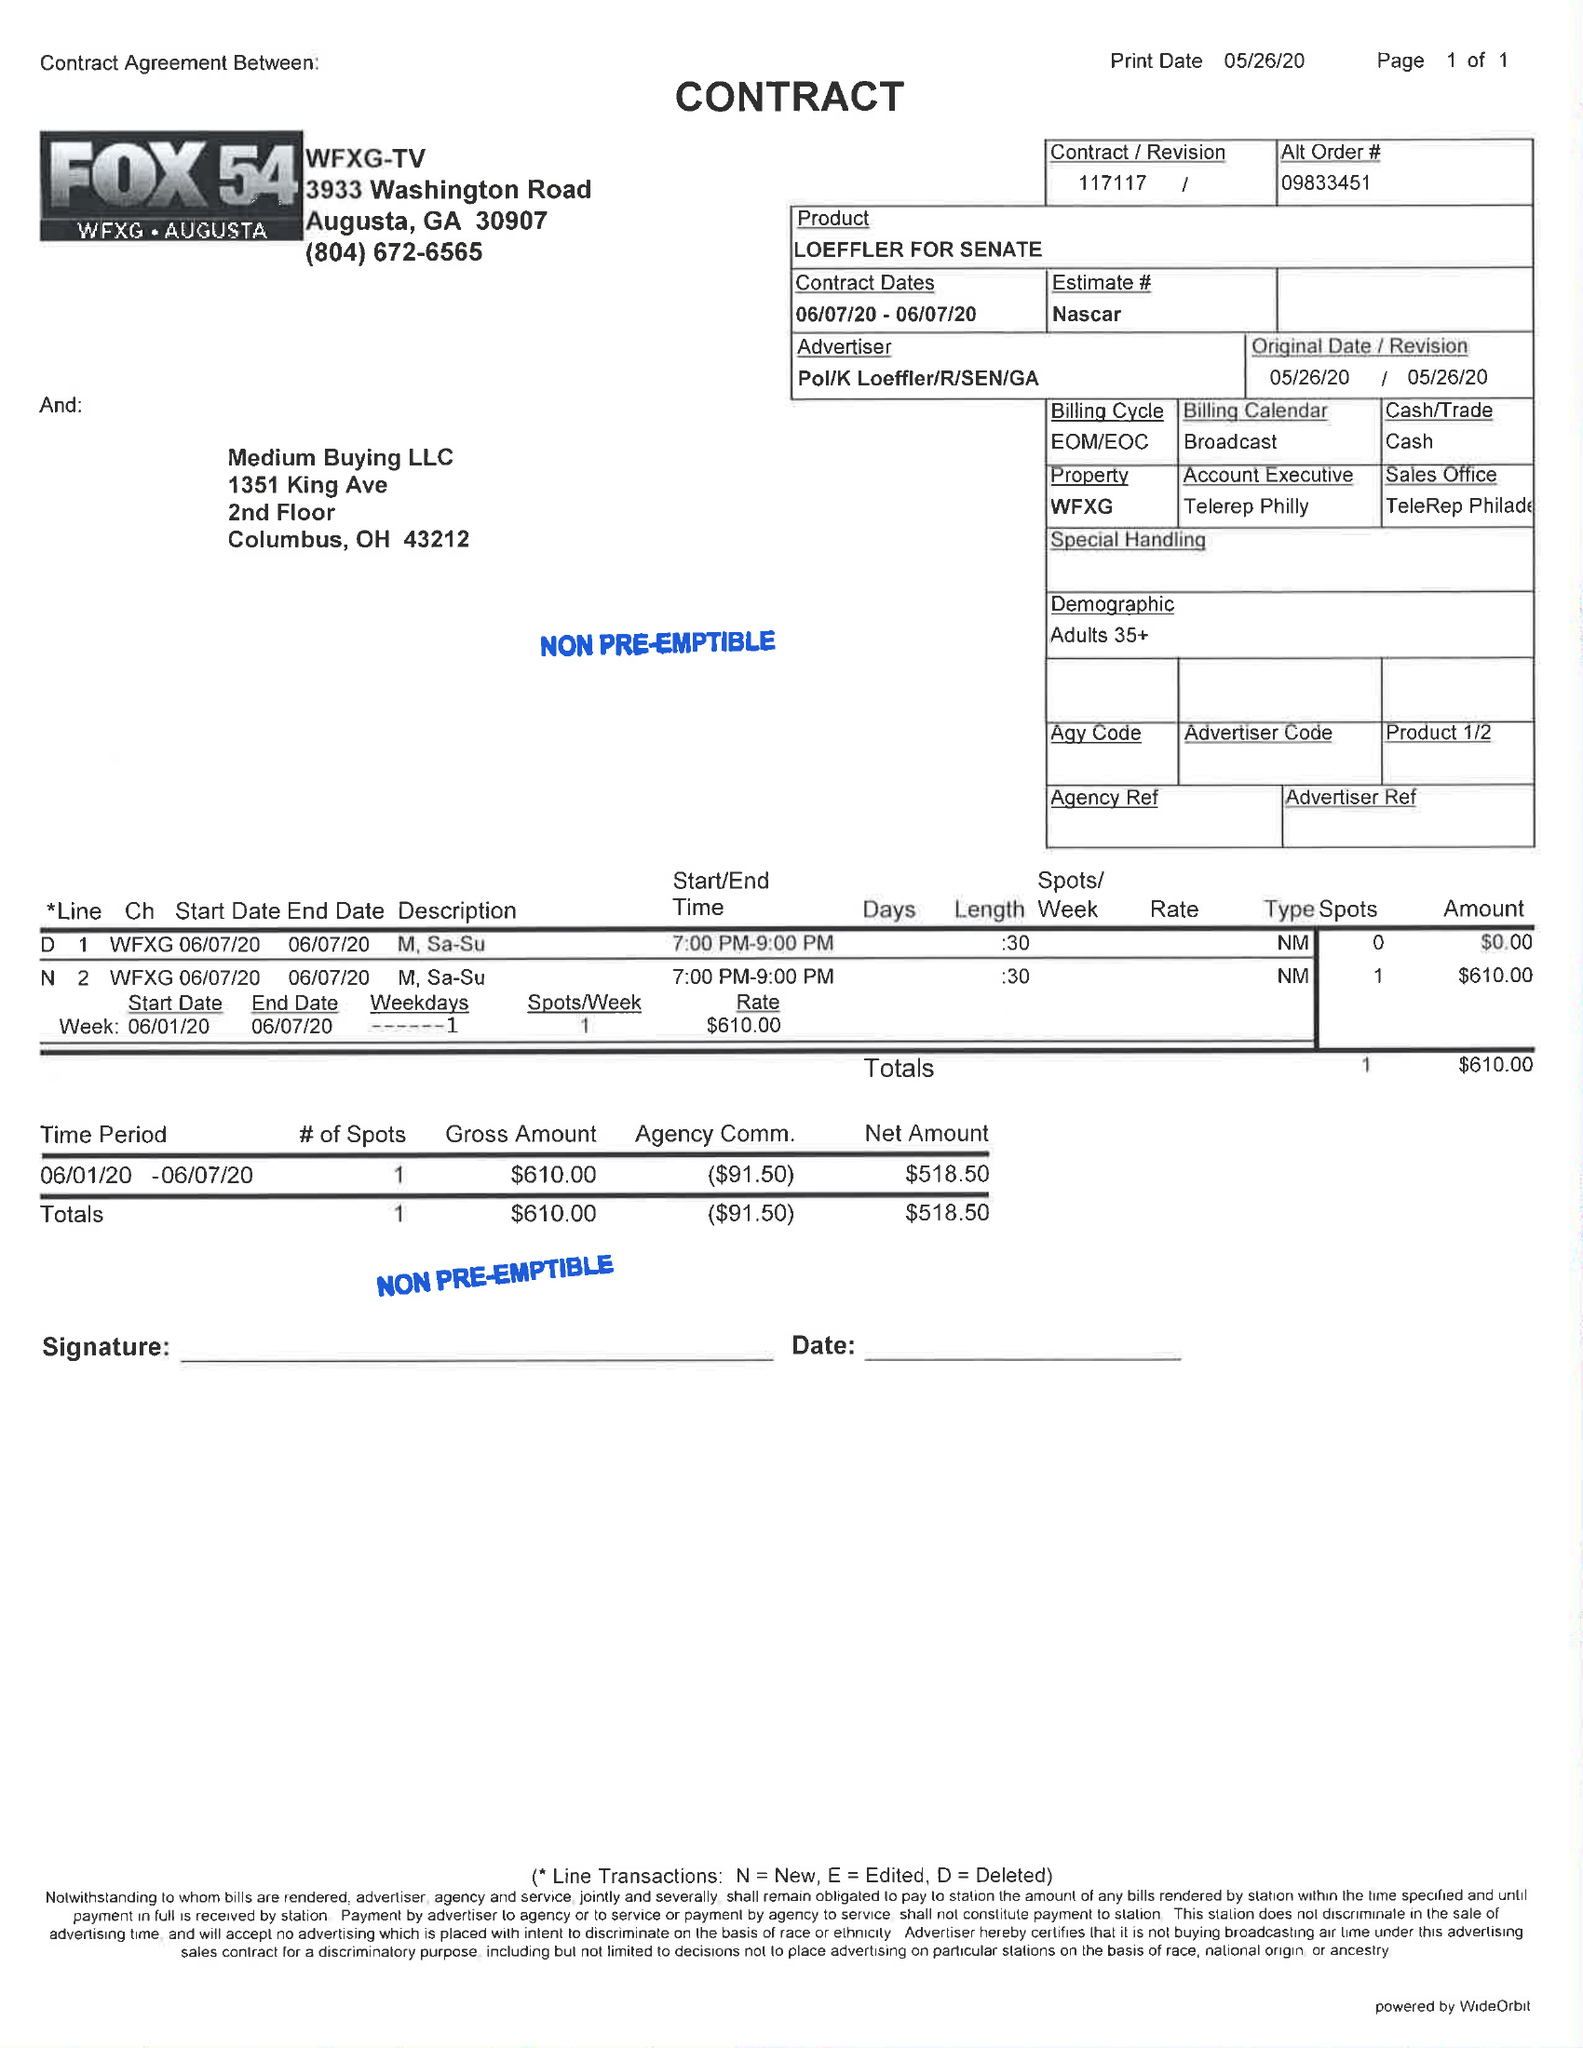What is the value for the advertiser?
Answer the question using a single word or phrase. POL/KLOEFFLER/R/SEN/GA 